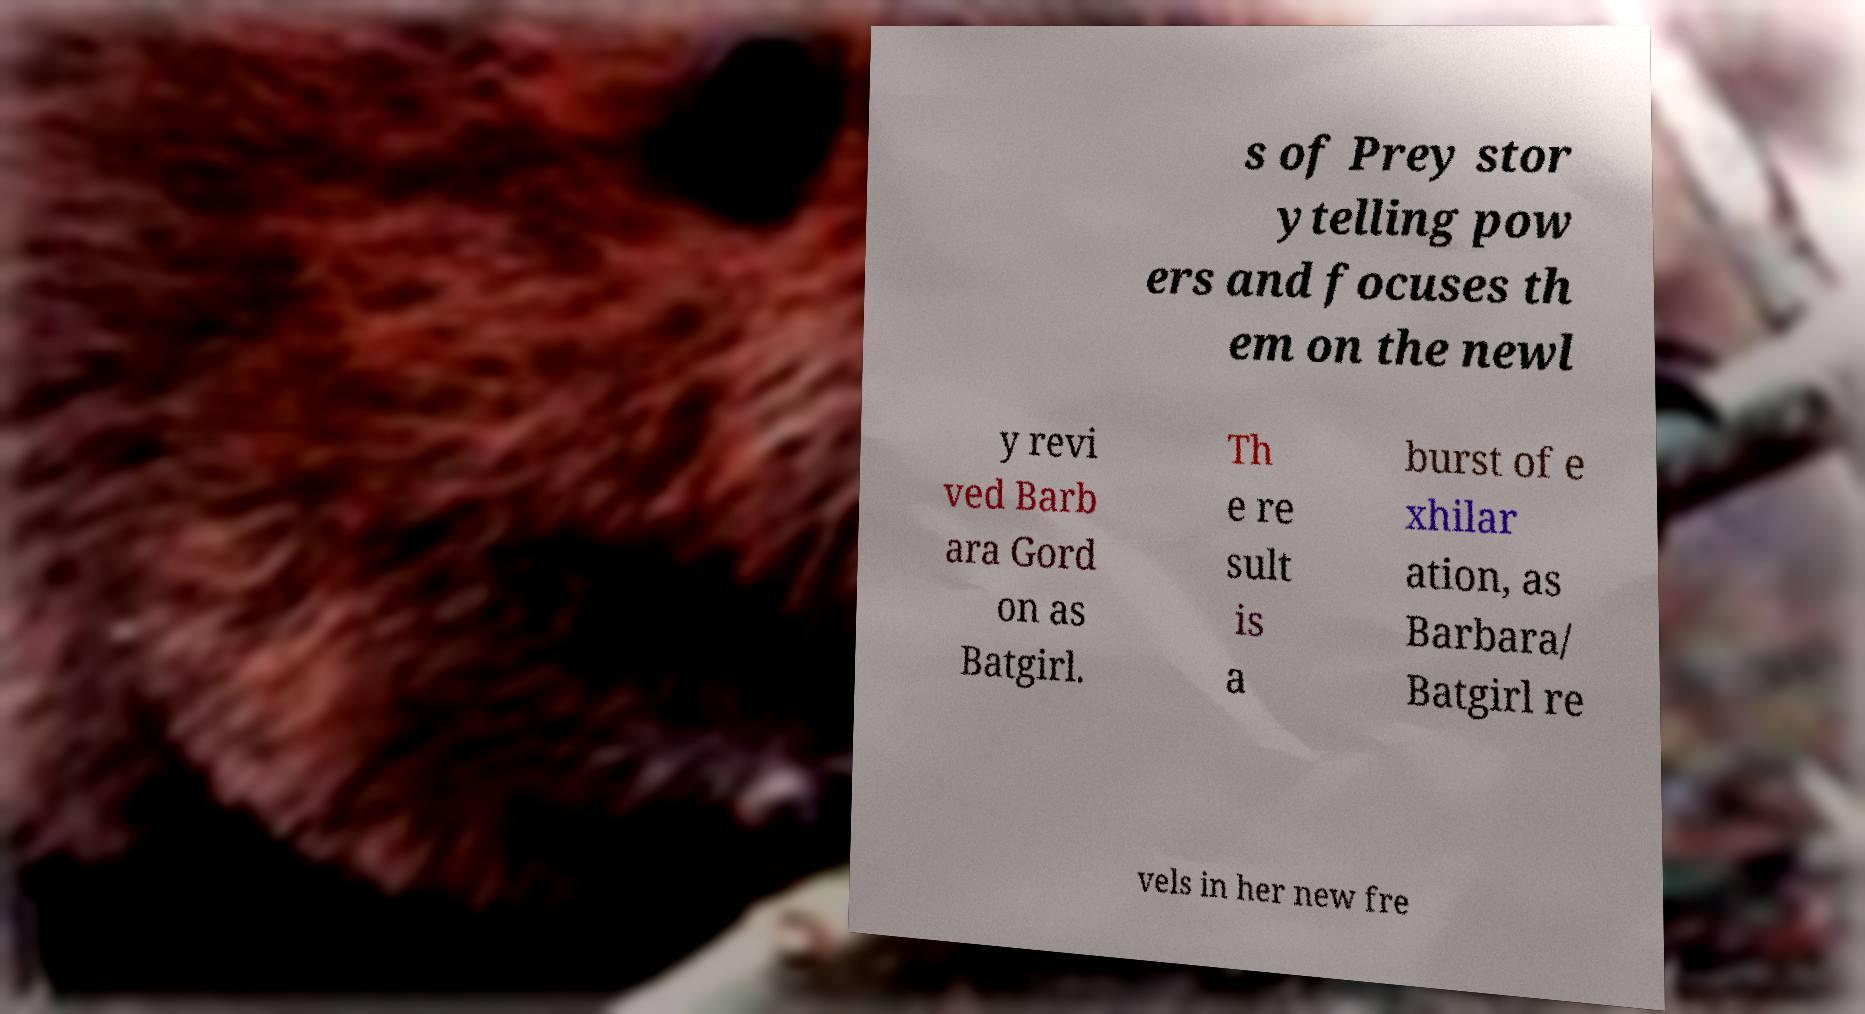Can you read and provide the text displayed in the image?This photo seems to have some interesting text. Can you extract and type it out for me? s of Prey stor ytelling pow ers and focuses th em on the newl y revi ved Barb ara Gord on as Batgirl. Th e re sult is a burst of e xhilar ation, as Barbara/ Batgirl re vels in her new fre 